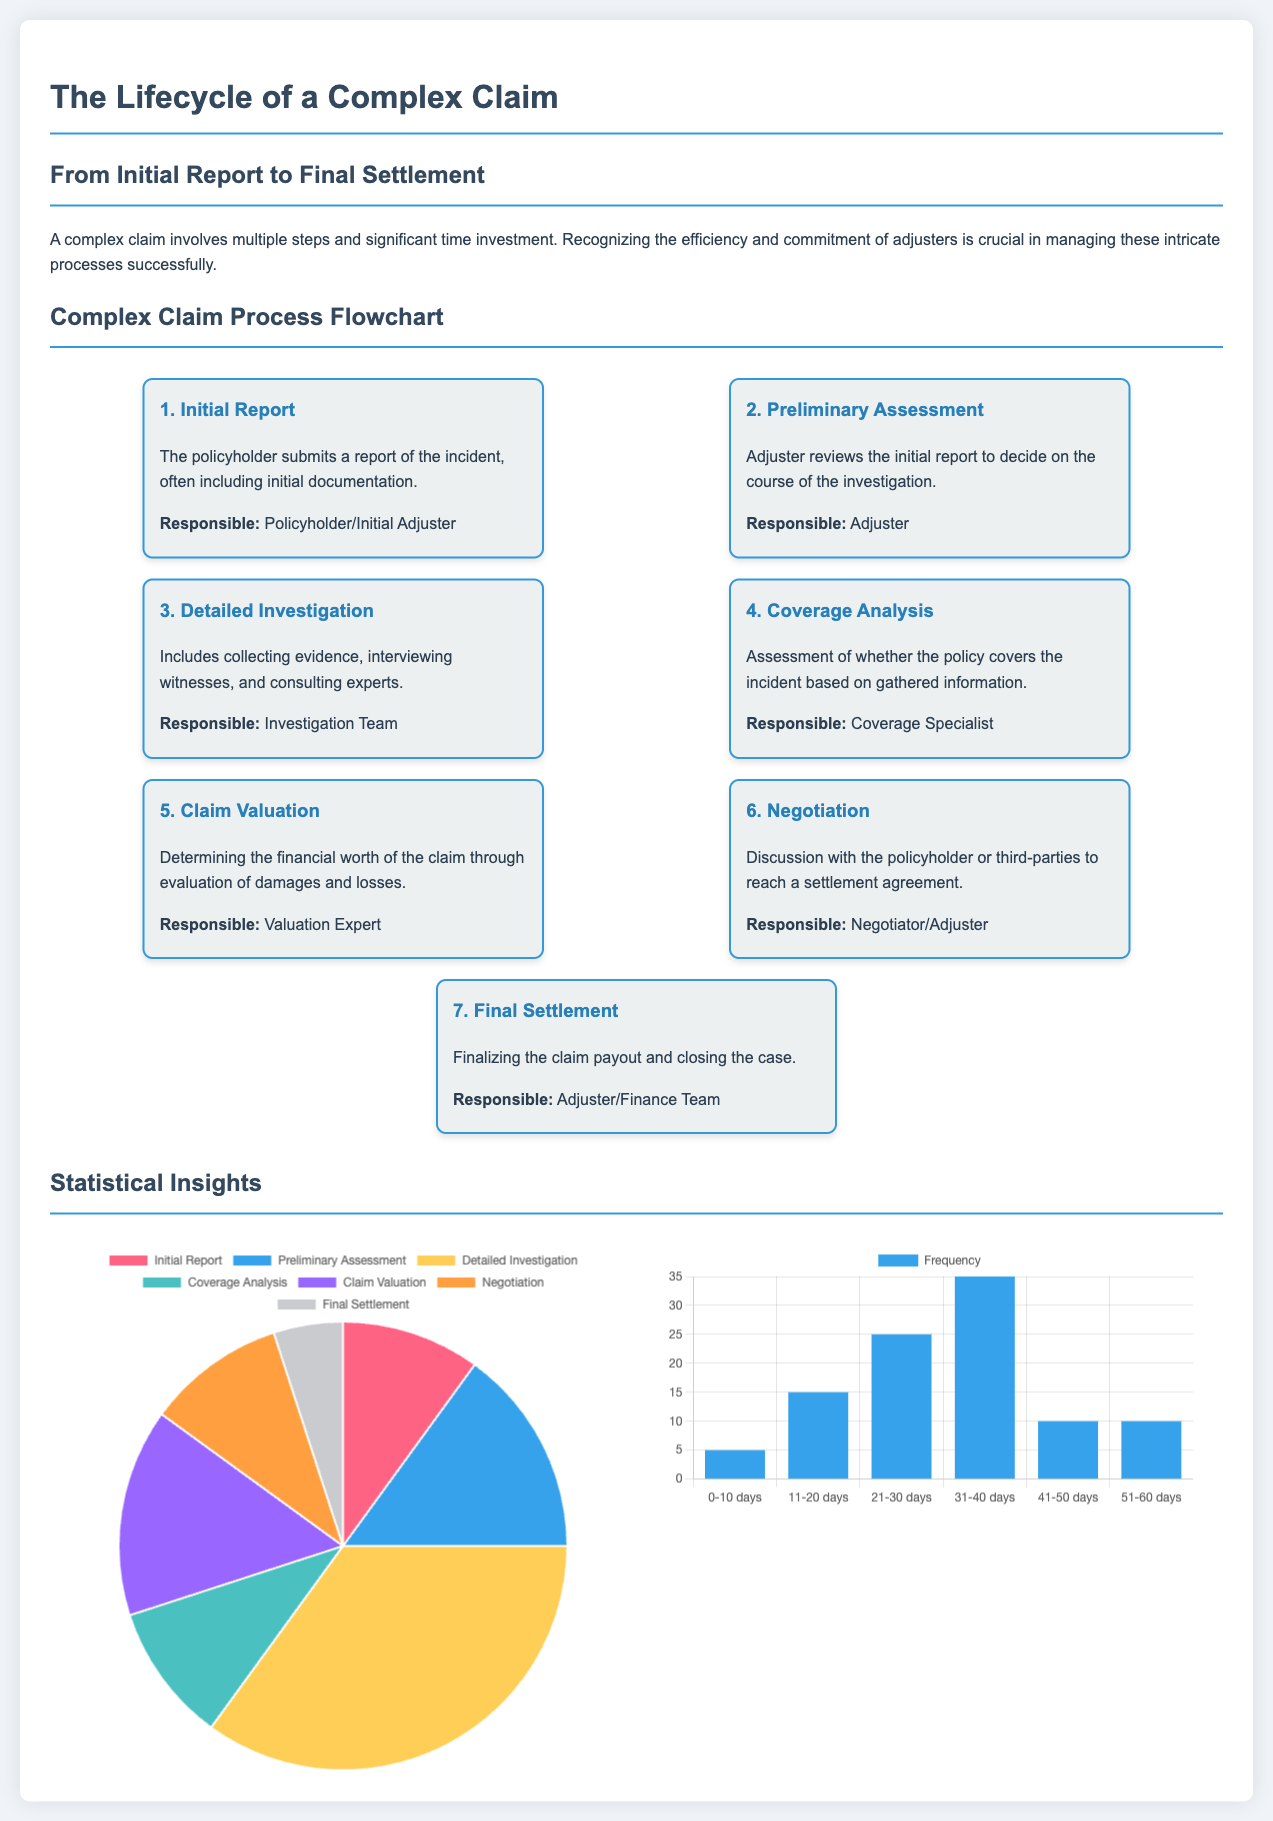What is the first step in the complex claim process? The first step outlined in the flowchart is the Initial Report submitted by the policyholder.
Answer: Initial Report How many steps are there in the complex claim process? The flowchart details seven distinct steps in the complex claim process.
Answer: Seven What stage involves the assessment of policy coverage? The stage that involves analyzing the policy coverage based on the incident information is called Coverage Analysis.
Answer: Coverage Analysis What is the percentage of time spent on Detailed Investigation? The pie chart shows that 35% of the time is spent on the Detailed Investigation stage.
Answer: 35% What is the frequency for claims taking 21-30 days for investigation? The histogram reveals that the frequency for claims taking 21-30 days is 25.
Answer: 25 Which stage has the least time distribution according to the pie chart? The Final Settlement stage has the least time distribution in the pie chart.
Answer: Final Settlement What color represents the Claim Valuation in the pie chart? The color representing Claim Valuation in the pie chart is yellow.
Answer: Yellow Which stage is responsible for negotiating settlements? The stage responsible for negotiating settlements is Negotiation.
Answer: Negotiation What is the title of the infographic? The title of the infographic is The Lifecycle of a Complex Claim.
Answer: The Lifecycle of a Complex Claim 